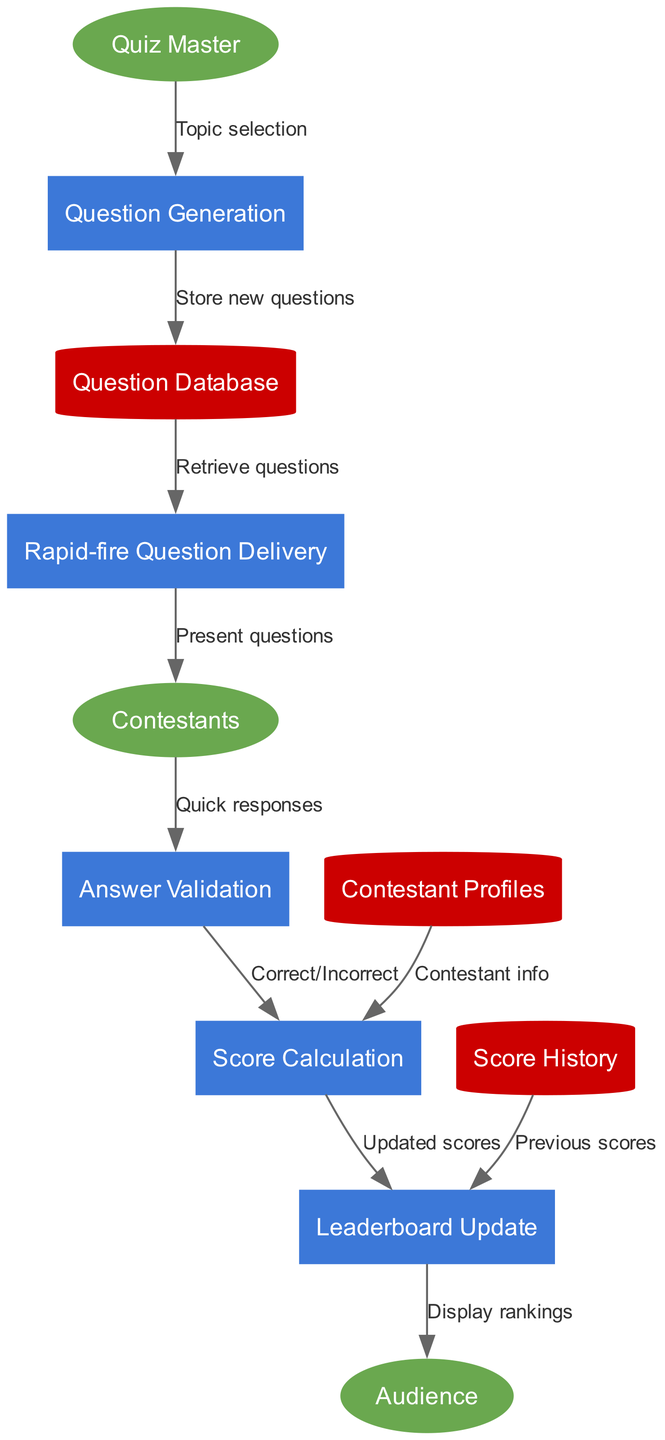What are the external entities in the diagram? The external entities are the components that interact with the processes, specifically mentioned as "Quiz Master," "Contestants," and "Audience."
Answer: Quiz Master, Contestants, Audience How many processes are depicted in the diagram? The diagram lists five distinct processes: "Question Generation," "Rapid-fire Question Delivery," "Answer Validation," "Score Calculation," and "Leaderboard Update," making a total of five.
Answer: 5 What is the flow from "Contestants" to "Answer Validation"? The flow is labeled "Quick responses," indicating that contestants send their answers to the answer validation process.
Answer: Quick responses Which data store provides contestant information to "Score Calculation"? The "Contestant Profiles" data store supplies the necessary contestant information required for score calculation.
Answer: Contestant Profiles What is the last process that interacts with the audience? The last process that interacts with the audience is "Leaderboard Update," as it displays the rankings to the audience based on the scores calculated.
Answer: Leaderboard Update How does "Score Calculation" receive previous scores? "Score Calculation" obtains previous scores through a data flow from the "Score History" data store, which keeps track of historical scores for contestants.
Answer: Score History From which process does the "Audience" receive information? The "Audience" receives information from the "Leaderboard Update" process, which displays the rankings based on updated scores from the contest.
Answer: Leaderboard Update What is the purpose of the "Question Database"? The "Question Database" stores new questions generated in the "Question Generation" process, and it serves as a repository from which questions are retrieved for delivery to contestants.
Answer: Store new questions Which external entity provides the topic selection? The "Quiz Master" is responsible for providing the topic selection that informs the "Question Generation" process.
Answer: Quiz Master What is the relationship between "Answer Validation" and "Score Calculation"? The relationship is that "Answer Validation" provides the information of whether answers are "Correct" or "Incorrect," which is essential for the subsequent "Score Calculation" process.
Answer: Correct/Incorrect 